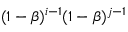<formula> <loc_0><loc_0><loc_500><loc_500>( 1 - \beta ) ^ { i - 1 } ( 1 - \beta ) ^ { j - 1 }</formula> 